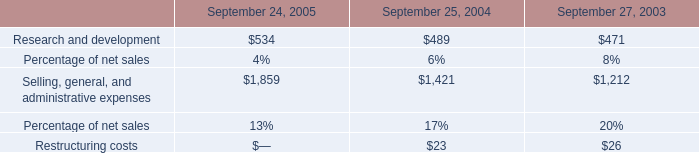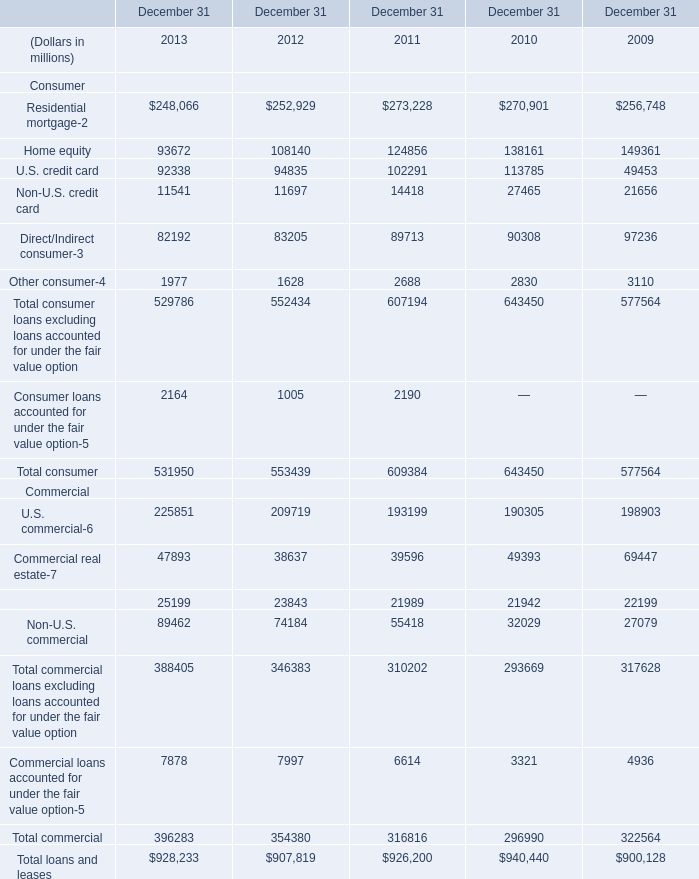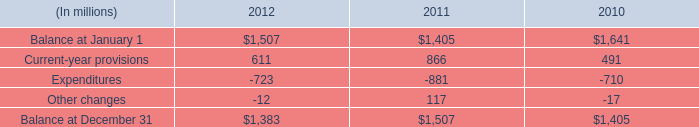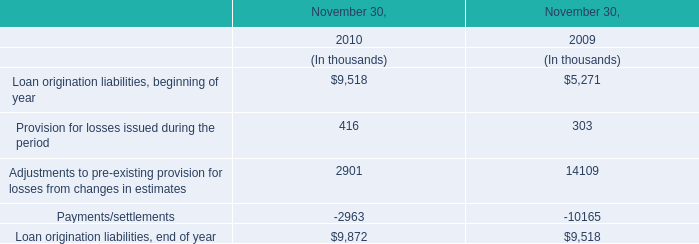What is the sum of Balance at December 31 of 2012, Selling, general, and administrative expenses of September 25, 2004, and Total commercial loans excluding loans accounted for under the fair value option Commercial of December 31 2011 ? 
Computations: ((1383.0 + 1421.0) + 310202.0)
Answer: 313006.0. 